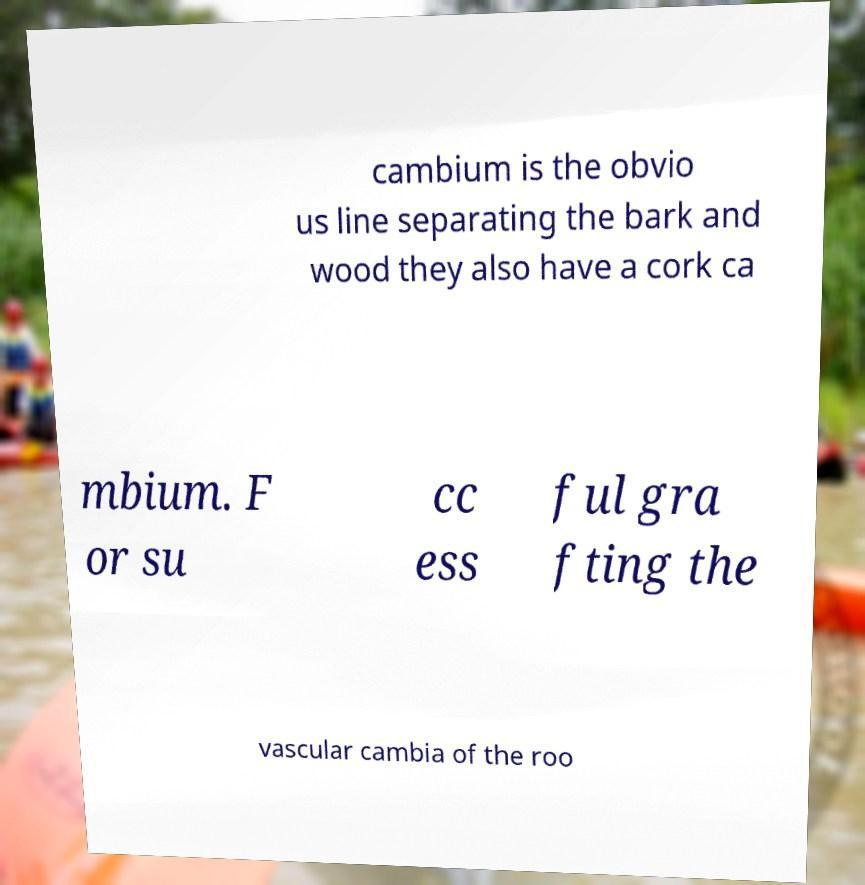I need the written content from this picture converted into text. Can you do that? cambium is the obvio us line separating the bark and wood they also have a cork ca mbium. F or su cc ess ful gra fting the vascular cambia of the roo 